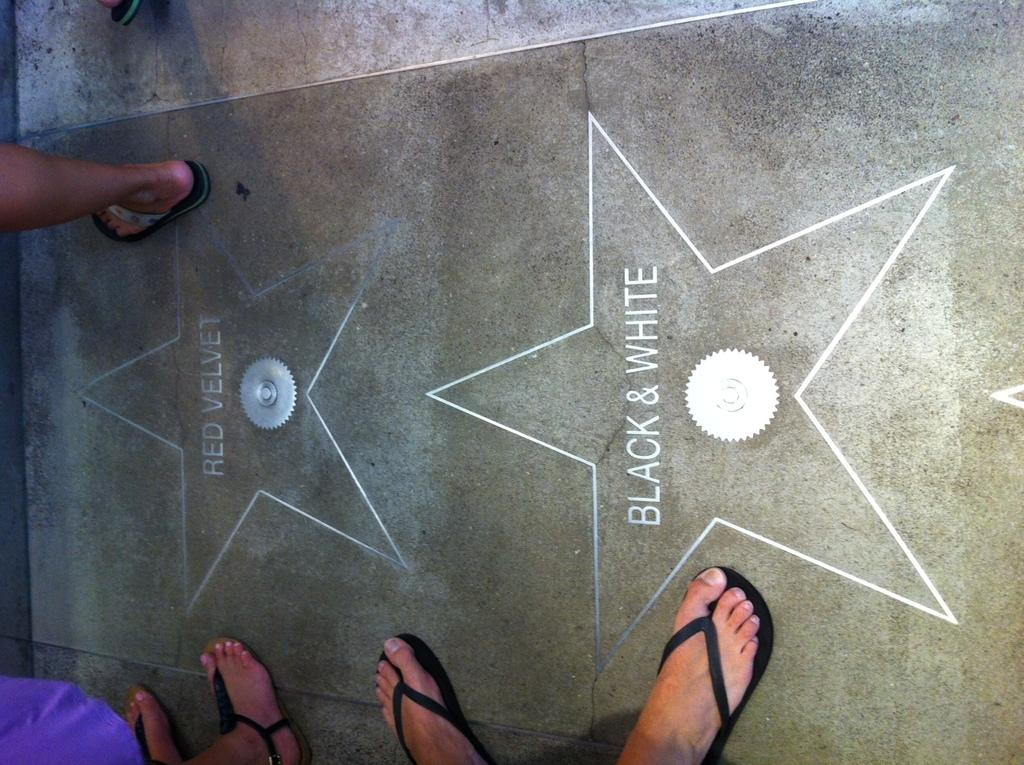What can be seen at the bottom of the image? There are legs of persons in the image. What is the main design element in the middle of the image? There are star designs in the middle of the image. What type of quill is being used by the person in the image? There is no quill present in the image; it only shows legs of persons and star designs. 